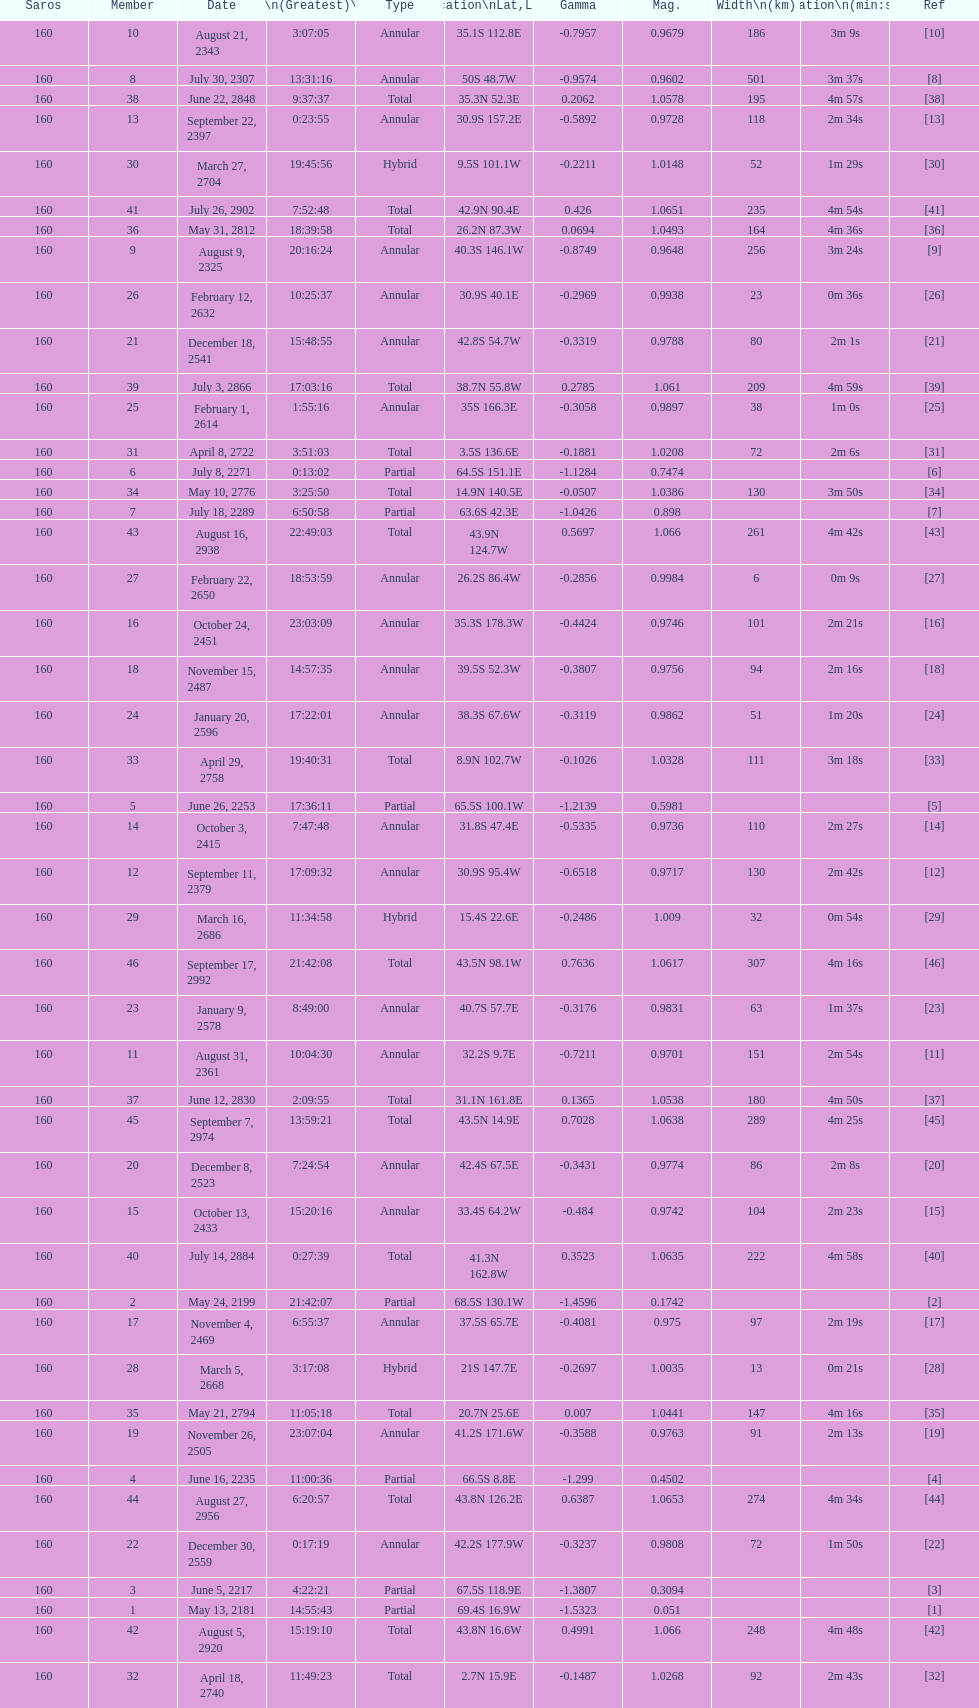How many partial members will occur before the first annular? 7. 